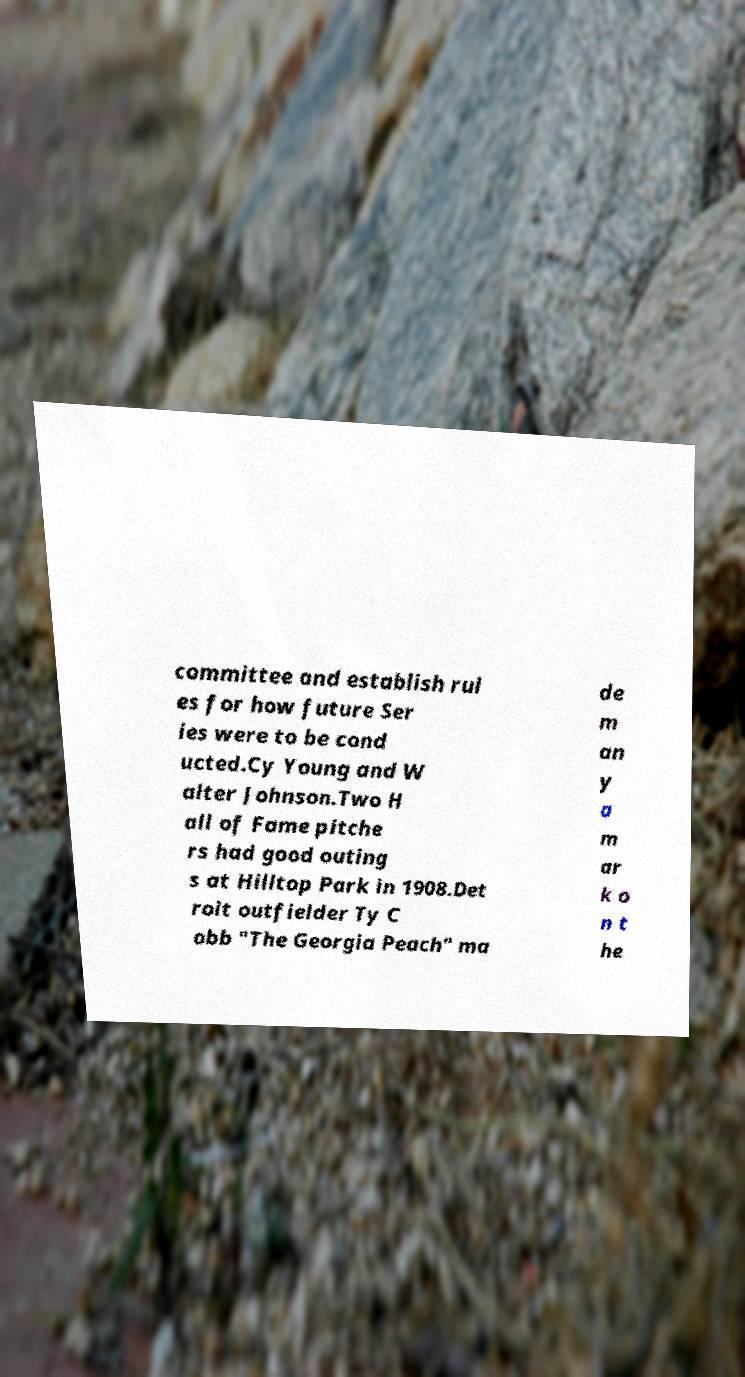Could you extract and type out the text from this image? committee and establish rul es for how future Ser ies were to be cond ucted.Cy Young and W alter Johnson.Two H all of Fame pitche rs had good outing s at Hilltop Park in 1908.Det roit outfielder Ty C obb "The Georgia Peach" ma de m an y a m ar k o n t he 